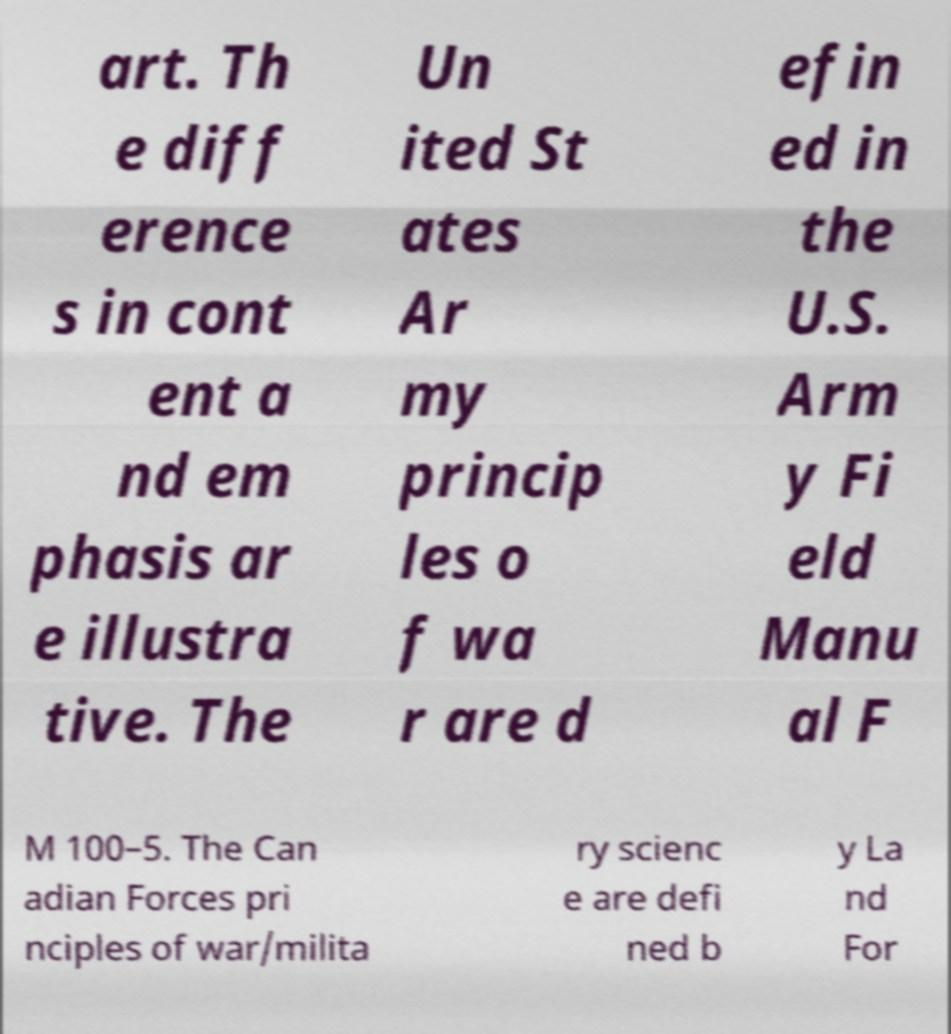Can you read and provide the text displayed in the image?This photo seems to have some interesting text. Can you extract and type it out for me? art. Th e diff erence s in cont ent a nd em phasis ar e illustra tive. The Un ited St ates Ar my princip les o f wa r are d efin ed in the U.S. Arm y Fi eld Manu al F M 100–5. The Can adian Forces pri nciples of war/milita ry scienc e are defi ned b y La nd For 